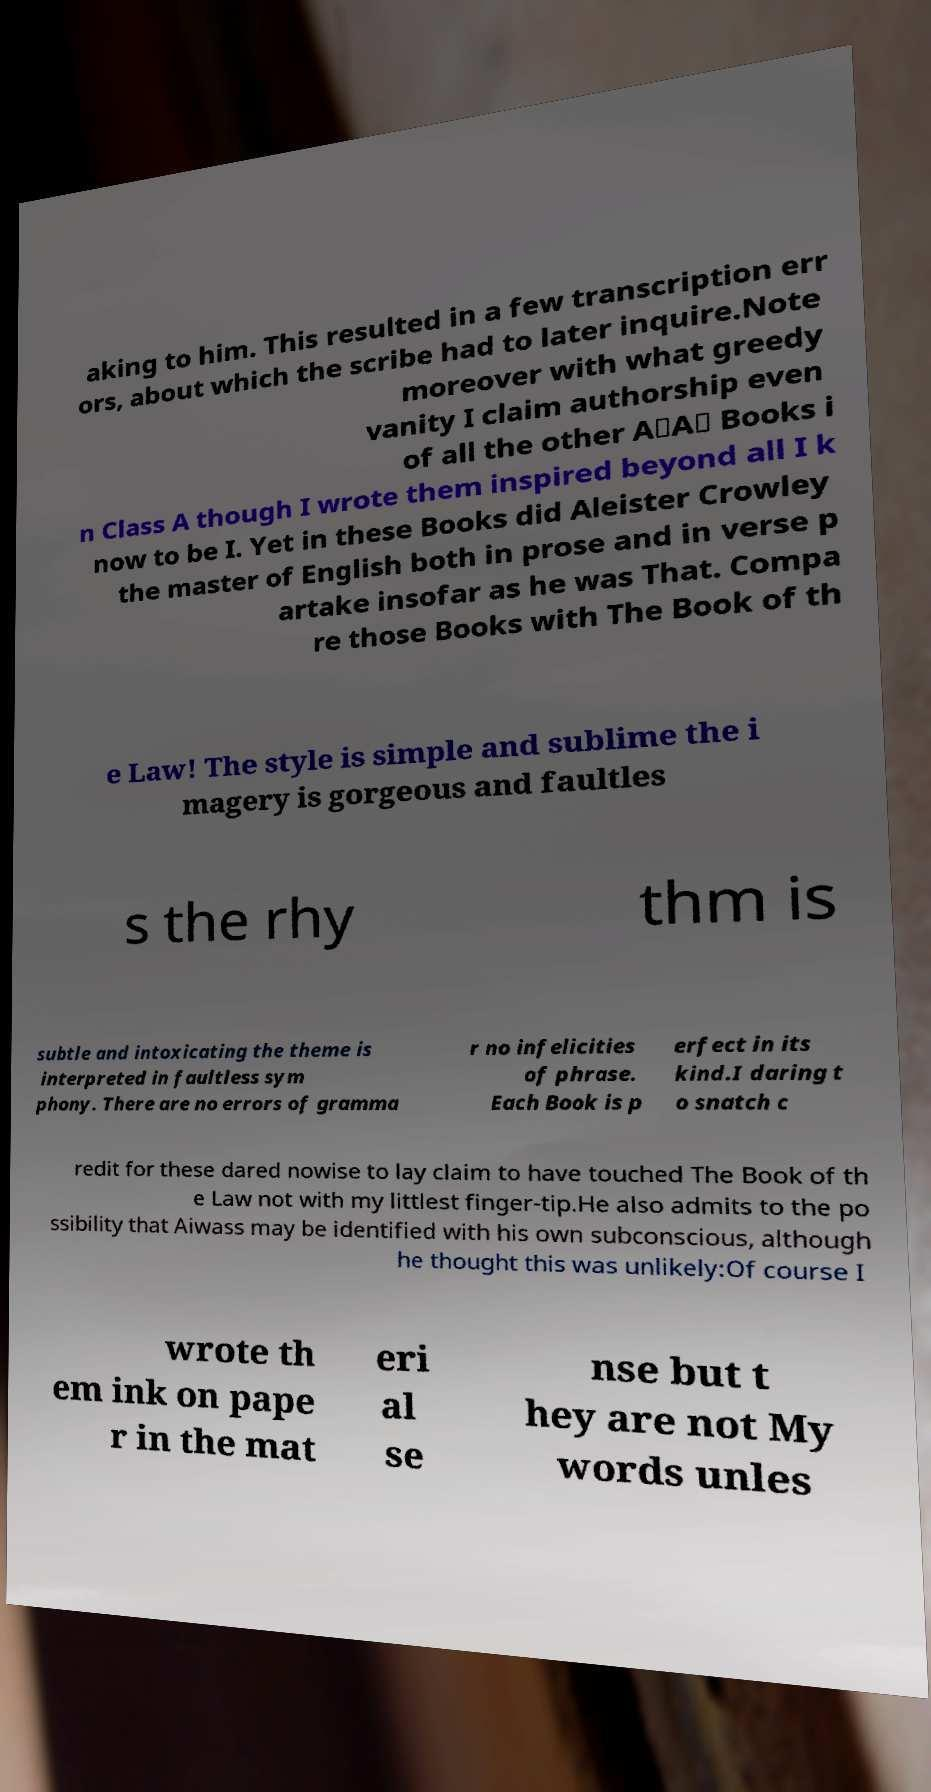Can you read and provide the text displayed in the image?This photo seems to have some interesting text. Can you extract and type it out for me? aking to him. This resulted in a few transcription err ors, about which the scribe had to later inquire.Note moreover with what greedy vanity I claim authorship even of all the other A∴A∴ Books i n Class A though I wrote them inspired beyond all I k now to be I. Yet in these Books did Aleister Crowley the master of English both in prose and in verse p artake insofar as he was That. Compa re those Books with The Book of th e Law! The style is simple and sublime the i magery is gorgeous and faultles s the rhy thm is subtle and intoxicating the theme is interpreted in faultless sym phony. There are no errors of gramma r no infelicities of phrase. Each Book is p erfect in its kind.I daring t o snatch c redit for these dared nowise to lay claim to have touched The Book of th e Law not with my littlest finger-tip.He also admits to the po ssibility that Aiwass may be identified with his own subconscious, although he thought this was unlikely:Of course I wrote th em ink on pape r in the mat eri al se nse but t hey are not My words unles 